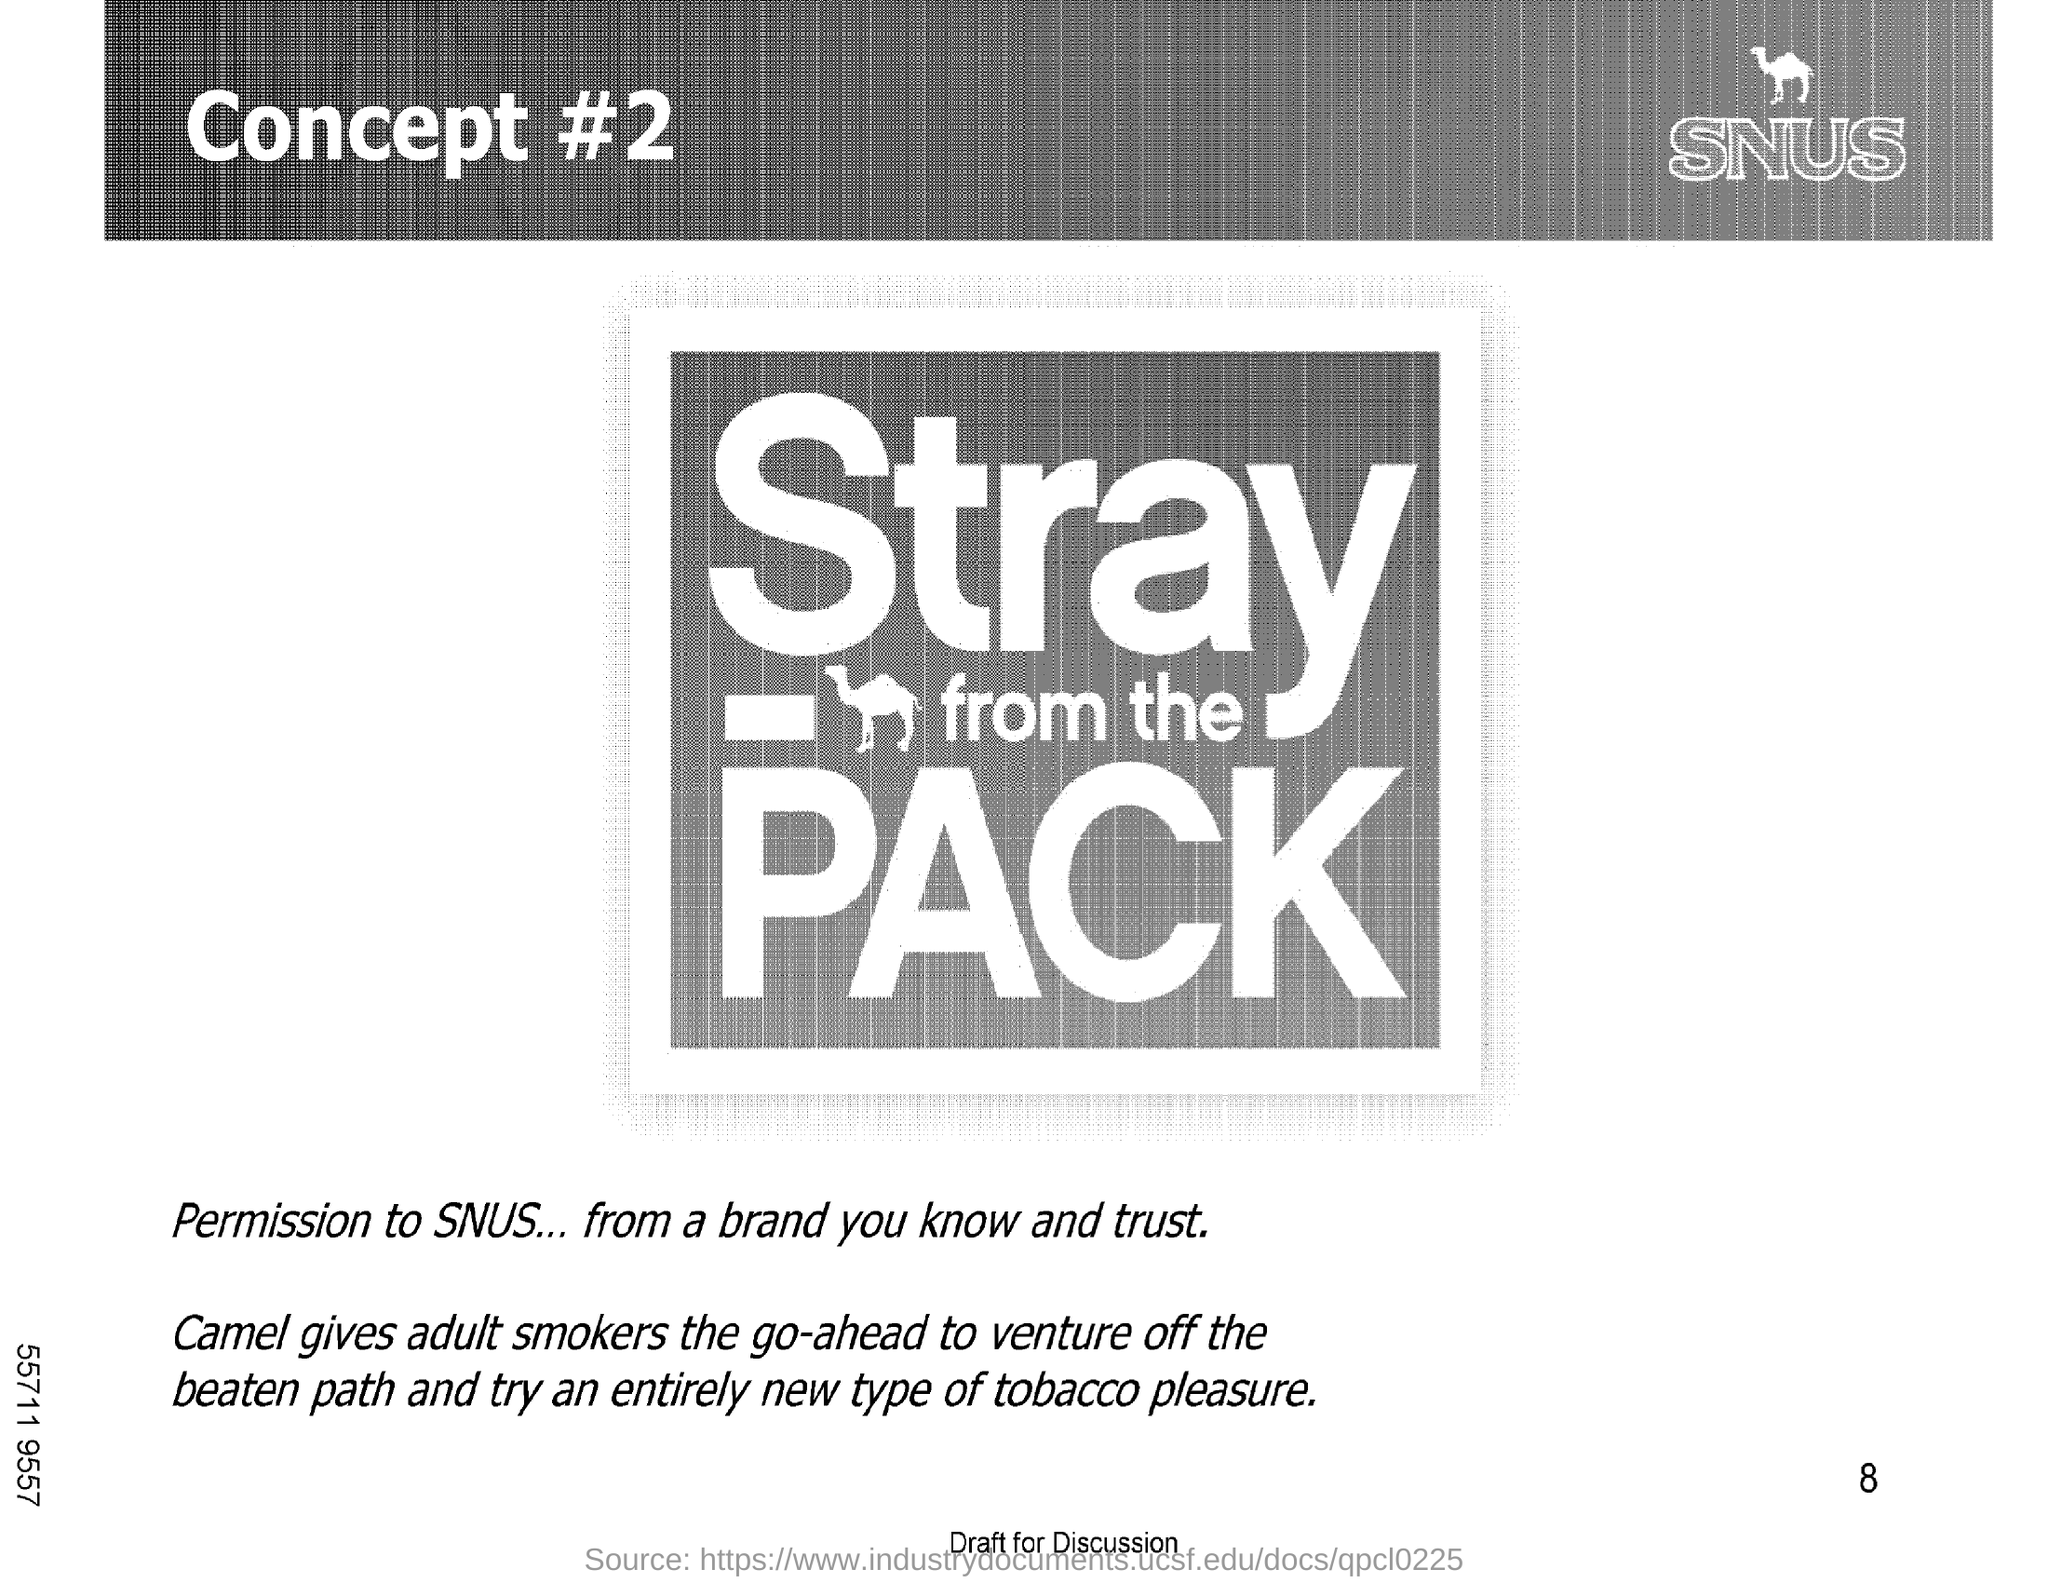Outline some significant characteristics in this image. The heading of the document is Concept #2. The camel is the animal that is mentioned in the document. 